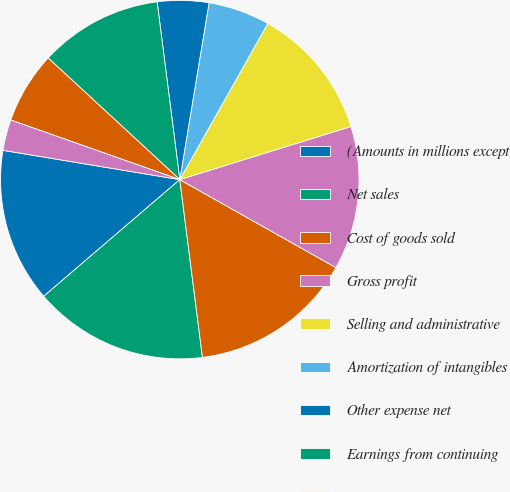Convert chart to OTSL. <chart><loc_0><loc_0><loc_500><loc_500><pie_chart><fcel>(Amounts in millions except<fcel>Net sales<fcel>Cost of goods sold<fcel>Gross profit<fcel>Selling and administrative<fcel>Amortization of intangibles<fcel>Other expense net<fcel>Earnings from continuing<fcel>Interest expense<fcel>Interest income<nl><fcel>13.89%<fcel>15.74%<fcel>14.81%<fcel>12.96%<fcel>12.04%<fcel>5.56%<fcel>4.63%<fcel>11.11%<fcel>6.48%<fcel>2.78%<nl></chart> 